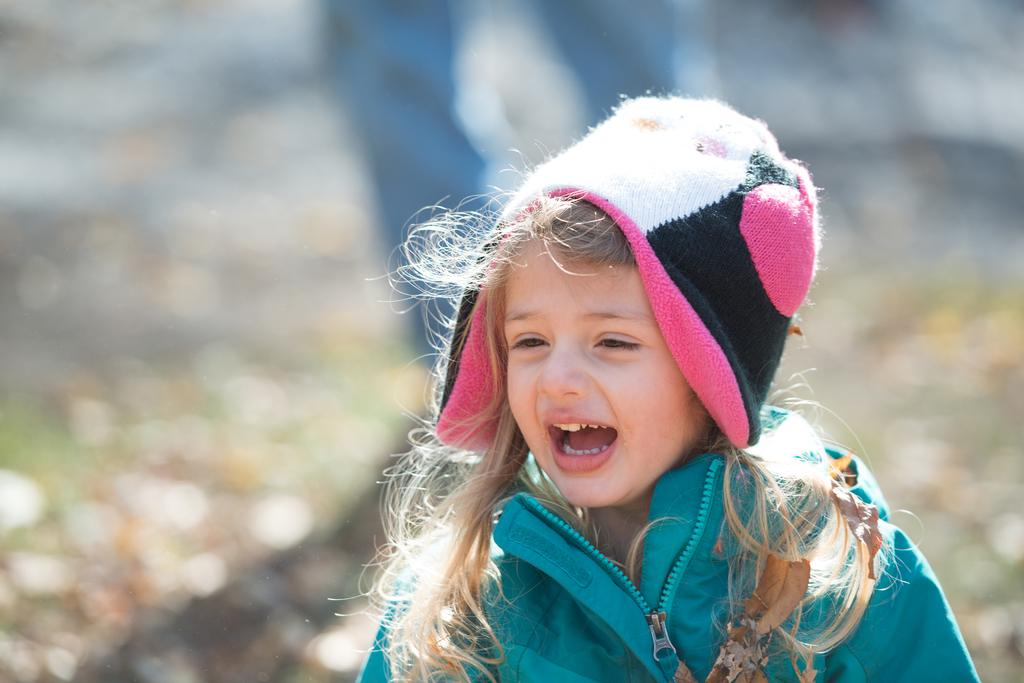Who is the main subject in the picture? There is a girl in the picture. What is the girl wearing? The girl is wearing a blue jacket. What is the girl's facial expression in the picture? The girl is smiling. Can you describe the background of the image? The background of the image is blurred. How many kittens are playing on the square in the image? There are no kittens or squares present in the image; it features a girl wearing a blue jacket and smiling. 